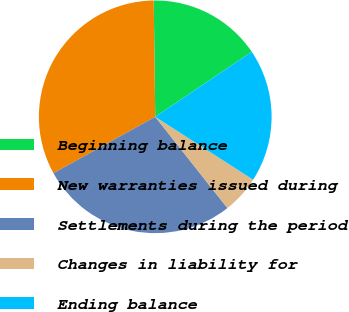Convert chart. <chart><loc_0><loc_0><loc_500><loc_500><pie_chart><fcel>Beginning balance<fcel>New warranties issued during<fcel>Settlements during the period<fcel>Changes in liability for<fcel>Ending balance<nl><fcel>15.77%<fcel>32.85%<fcel>27.6%<fcel>5.26%<fcel>18.53%<nl></chart> 